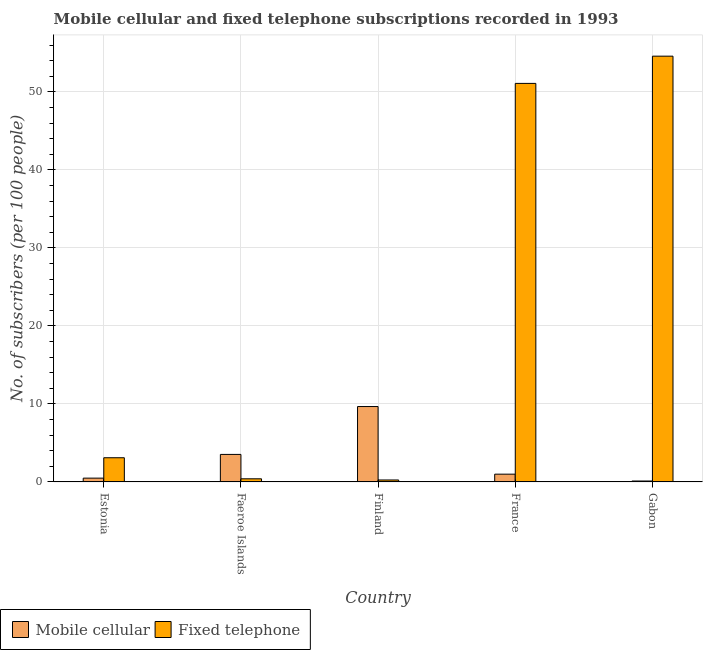How many different coloured bars are there?
Your answer should be compact. 2. How many groups of bars are there?
Make the answer very short. 5. Are the number of bars per tick equal to the number of legend labels?
Offer a terse response. Yes. Are the number of bars on each tick of the X-axis equal?
Your response must be concise. Yes. How many bars are there on the 4th tick from the left?
Provide a short and direct response. 2. What is the number of fixed telephone subscribers in France?
Offer a very short reply. 51.1. Across all countries, what is the maximum number of fixed telephone subscribers?
Ensure brevity in your answer.  54.59. Across all countries, what is the minimum number of fixed telephone subscribers?
Give a very brief answer. 0.25. In which country was the number of mobile cellular subscribers maximum?
Give a very brief answer. Finland. In which country was the number of mobile cellular subscribers minimum?
Give a very brief answer. Gabon. What is the total number of mobile cellular subscribers in the graph?
Give a very brief answer. 14.79. What is the difference between the number of fixed telephone subscribers in Estonia and that in Finland?
Provide a short and direct response. 2.85. What is the difference between the number of mobile cellular subscribers in Estonia and the number of fixed telephone subscribers in France?
Offer a terse response. -50.61. What is the average number of fixed telephone subscribers per country?
Offer a terse response. 21.89. What is the difference between the number of mobile cellular subscribers and number of fixed telephone subscribers in Estonia?
Make the answer very short. -2.62. What is the ratio of the number of mobile cellular subscribers in Estonia to that in Finland?
Keep it short and to the point. 0.05. Is the number of mobile cellular subscribers in Estonia less than that in Finland?
Make the answer very short. Yes. Is the difference between the number of mobile cellular subscribers in France and Gabon greater than the difference between the number of fixed telephone subscribers in France and Gabon?
Give a very brief answer. Yes. What is the difference between the highest and the second highest number of mobile cellular subscribers?
Make the answer very short. 6.14. What is the difference between the highest and the lowest number of fixed telephone subscribers?
Your answer should be compact. 54.34. In how many countries, is the number of mobile cellular subscribers greater than the average number of mobile cellular subscribers taken over all countries?
Ensure brevity in your answer.  2. Is the sum of the number of fixed telephone subscribers in Estonia and Faeroe Islands greater than the maximum number of mobile cellular subscribers across all countries?
Provide a succinct answer. No. What does the 1st bar from the left in Estonia represents?
Keep it short and to the point. Mobile cellular. What does the 1st bar from the right in Finland represents?
Your answer should be compact. Fixed telephone. How many bars are there?
Provide a short and direct response. 10. How many countries are there in the graph?
Offer a very short reply. 5. Are the values on the major ticks of Y-axis written in scientific E-notation?
Ensure brevity in your answer.  No. Does the graph contain any zero values?
Make the answer very short. No. What is the title of the graph?
Offer a very short reply. Mobile cellular and fixed telephone subscriptions recorded in 1993. What is the label or title of the Y-axis?
Your answer should be compact. No. of subscribers (per 100 people). What is the No. of subscribers (per 100 people) in Mobile cellular in Estonia?
Your response must be concise. 0.48. What is the No. of subscribers (per 100 people) of Fixed telephone in Estonia?
Offer a very short reply. 3.1. What is the No. of subscribers (per 100 people) in Mobile cellular in Faeroe Islands?
Provide a succinct answer. 3.53. What is the No. of subscribers (per 100 people) of Fixed telephone in Faeroe Islands?
Keep it short and to the point. 0.4. What is the No. of subscribers (per 100 people) of Mobile cellular in Finland?
Your answer should be compact. 9.66. What is the No. of subscribers (per 100 people) of Fixed telephone in Finland?
Keep it short and to the point. 0.25. What is the No. of subscribers (per 100 people) in Mobile cellular in France?
Your response must be concise. 0.99. What is the No. of subscribers (per 100 people) in Fixed telephone in France?
Your response must be concise. 51.1. What is the No. of subscribers (per 100 people) of Mobile cellular in Gabon?
Make the answer very short. 0.12. What is the No. of subscribers (per 100 people) of Fixed telephone in Gabon?
Offer a very short reply. 54.59. Across all countries, what is the maximum No. of subscribers (per 100 people) of Mobile cellular?
Provide a short and direct response. 9.66. Across all countries, what is the maximum No. of subscribers (per 100 people) of Fixed telephone?
Provide a short and direct response. 54.59. Across all countries, what is the minimum No. of subscribers (per 100 people) of Mobile cellular?
Provide a short and direct response. 0.12. Across all countries, what is the minimum No. of subscribers (per 100 people) in Fixed telephone?
Ensure brevity in your answer.  0.25. What is the total No. of subscribers (per 100 people) of Mobile cellular in the graph?
Offer a very short reply. 14.79. What is the total No. of subscribers (per 100 people) of Fixed telephone in the graph?
Keep it short and to the point. 109.44. What is the difference between the No. of subscribers (per 100 people) of Mobile cellular in Estonia and that in Faeroe Islands?
Offer a terse response. -3.04. What is the difference between the No. of subscribers (per 100 people) in Fixed telephone in Estonia and that in Faeroe Islands?
Provide a succinct answer. 2.7. What is the difference between the No. of subscribers (per 100 people) of Mobile cellular in Estonia and that in Finland?
Ensure brevity in your answer.  -9.18. What is the difference between the No. of subscribers (per 100 people) in Fixed telephone in Estonia and that in Finland?
Provide a short and direct response. 2.85. What is the difference between the No. of subscribers (per 100 people) of Mobile cellular in Estonia and that in France?
Provide a short and direct response. -0.51. What is the difference between the No. of subscribers (per 100 people) of Fixed telephone in Estonia and that in France?
Ensure brevity in your answer.  -48. What is the difference between the No. of subscribers (per 100 people) of Mobile cellular in Estonia and that in Gabon?
Your answer should be compact. 0.37. What is the difference between the No. of subscribers (per 100 people) of Fixed telephone in Estonia and that in Gabon?
Ensure brevity in your answer.  -51.49. What is the difference between the No. of subscribers (per 100 people) of Mobile cellular in Faeroe Islands and that in Finland?
Make the answer very short. -6.14. What is the difference between the No. of subscribers (per 100 people) of Fixed telephone in Faeroe Islands and that in Finland?
Keep it short and to the point. 0.15. What is the difference between the No. of subscribers (per 100 people) in Mobile cellular in Faeroe Islands and that in France?
Offer a very short reply. 2.53. What is the difference between the No. of subscribers (per 100 people) of Fixed telephone in Faeroe Islands and that in France?
Your response must be concise. -50.7. What is the difference between the No. of subscribers (per 100 people) in Mobile cellular in Faeroe Islands and that in Gabon?
Give a very brief answer. 3.41. What is the difference between the No. of subscribers (per 100 people) in Fixed telephone in Faeroe Islands and that in Gabon?
Ensure brevity in your answer.  -54.19. What is the difference between the No. of subscribers (per 100 people) of Mobile cellular in Finland and that in France?
Provide a short and direct response. 8.67. What is the difference between the No. of subscribers (per 100 people) of Fixed telephone in Finland and that in France?
Offer a very short reply. -50.85. What is the difference between the No. of subscribers (per 100 people) in Mobile cellular in Finland and that in Gabon?
Your answer should be compact. 9.55. What is the difference between the No. of subscribers (per 100 people) in Fixed telephone in Finland and that in Gabon?
Offer a terse response. -54.34. What is the difference between the No. of subscribers (per 100 people) in Mobile cellular in France and that in Gabon?
Give a very brief answer. 0.88. What is the difference between the No. of subscribers (per 100 people) of Fixed telephone in France and that in Gabon?
Make the answer very short. -3.49. What is the difference between the No. of subscribers (per 100 people) of Mobile cellular in Estonia and the No. of subscribers (per 100 people) of Fixed telephone in Faeroe Islands?
Your answer should be very brief. 0.09. What is the difference between the No. of subscribers (per 100 people) in Mobile cellular in Estonia and the No. of subscribers (per 100 people) in Fixed telephone in Finland?
Your response must be concise. 0.24. What is the difference between the No. of subscribers (per 100 people) of Mobile cellular in Estonia and the No. of subscribers (per 100 people) of Fixed telephone in France?
Ensure brevity in your answer.  -50.61. What is the difference between the No. of subscribers (per 100 people) of Mobile cellular in Estonia and the No. of subscribers (per 100 people) of Fixed telephone in Gabon?
Give a very brief answer. -54.11. What is the difference between the No. of subscribers (per 100 people) of Mobile cellular in Faeroe Islands and the No. of subscribers (per 100 people) of Fixed telephone in Finland?
Your answer should be compact. 3.28. What is the difference between the No. of subscribers (per 100 people) in Mobile cellular in Faeroe Islands and the No. of subscribers (per 100 people) in Fixed telephone in France?
Your answer should be compact. -47.57. What is the difference between the No. of subscribers (per 100 people) of Mobile cellular in Faeroe Islands and the No. of subscribers (per 100 people) of Fixed telephone in Gabon?
Your response must be concise. -51.06. What is the difference between the No. of subscribers (per 100 people) of Mobile cellular in Finland and the No. of subscribers (per 100 people) of Fixed telephone in France?
Provide a short and direct response. -41.43. What is the difference between the No. of subscribers (per 100 people) of Mobile cellular in Finland and the No. of subscribers (per 100 people) of Fixed telephone in Gabon?
Ensure brevity in your answer.  -44.93. What is the difference between the No. of subscribers (per 100 people) of Mobile cellular in France and the No. of subscribers (per 100 people) of Fixed telephone in Gabon?
Keep it short and to the point. -53.6. What is the average No. of subscribers (per 100 people) of Mobile cellular per country?
Offer a very short reply. 2.96. What is the average No. of subscribers (per 100 people) in Fixed telephone per country?
Your answer should be very brief. 21.89. What is the difference between the No. of subscribers (per 100 people) in Mobile cellular and No. of subscribers (per 100 people) in Fixed telephone in Estonia?
Keep it short and to the point. -2.62. What is the difference between the No. of subscribers (per 100 people) in Mobile cellular and No. of subscribers (per 100 people) in Fixed telephone in Faeroe Islands?
Offer a terse response. 3.13. What is the difference between the No. of subscribers (per 100 people) in Mobile cellular and No. of subscribers (per 100 people) in Fixed telephone in Finland?
Ensure brevity in your answer.  9.42. What is the difference between the No. of subscribers (per 100 people) in Mobile cellular and No. of subscribers (per 100 people) in Fixed telephone in France?
Your response must be concise. -50.1. What is the difference between the No. of subscribers (per 100 people) in Mobile cellular and No. of subscribers (per 100 people) in Fixed telephone in Gabon?
Make the answer very short. -54.47. What is the ratio of the No. of subscribers (per 100 people) in Mobile cellular in Estonia to that in Faeroe Islands?
Your answer should be compact. 0.14. What is the ratio of the No. of subscribers (per 100 people) in Fixed telephone in Estonia to that in Faeroe Islands?
Provide a succinct answer. 7.77. What is the ratio of the No. of subscribers (per 100 people) in Mobile cellular in Estonia to that in Finland?
Your answer should be compact. 0.05. What is the ratio of the No. of subscribers (per 100 people) of Fixed telephone in Estonia to that in Finland?
Your answer should be very brief. 12.48. What is the ratio of the No. of subscribers (per 100 people) of Mobile cellular in Estonia to that in France?
Ensure brevity in your answer.  0.49. What is the ratio of the No. of subscribers (per 100 people) of Fixed telephone in Estonia to that in France?
Provide a short and direct response. 0.06. What is the ratio of the No. of subscribers (per 100 people) of Mobile cellular in Estonia to that in Gabon?
Your response must be concise. 4.14. What is the ratio of the No. of subscribers (per 100 people) in Fixed telephone in Estonia to that in Gabon?
Your answer should be compact. 0.06. What is the ratio of the No. of subscribers (per 100 people) in Mobile cellular in Faeroe Islands to that in Finland?
Provide a short and direct response. 0.36. What is the ratio of the No. of subscribers (per 100 people) of Fixed telephone in Faeroe Islands to that in Finland?
Provide a succinct answer. 1.61. What is the ratio of the No. of subscribers (per 100 people) of Mobile cellular in Faeroe Islands to that in France?
Offer a very short reply. 3.55. What is the ratio of the No. of subscribers (per 100 people) of Fixed telephone in Faeroe Islands to that in France?
Your answer should be compact. 0.01. What is the ratio of the No. of subscribers (per 100 people) in Mobile cellular in Faeroe Islands to that in Gabon?
Provide a succinct answer. 30.14. What is the ratio of the No. of subscribers (per 100 people) in Fixed telephone in Faeroe Islands to that in Gabon?
Give a very brief answer. 0.01. What is the ratio of the No. of subscribers (per 100 people) in Mobile cellular in Finland to that in France?
Provide a short and direct response. 9.73. What is the ratio of the No. of subscribers (per 100 people) in Fixed telephone in Finland to that in France?
Ensure brevity in your answer.  0. What is the ratio of the No. of subscribers (per 100 people) of Mobile cellular in Finland to that in Gabon?
Keep it short and to the point. 82.6. What is the ratio of the No. of subscribers (per 100 people) in Fixed telephone in Finland to that in Gabon?
Provide a short and direct response. 0. What is the ratio of the No. of subscribers (per 100 people) of Mobile cellular in France to that in Gabon?
Keep it short and to the point. 8.49. What is the ratio of the No. of subscribers (per 100 people) of Fixed telephone in France to that in Gabon?
Your response must be concise. 0.94. What is the difference between the highest and the second highest No. of subscribers (per 100 people) of Mobile cellular?
Keep it short and to the point. 6.14. What is the difference between the highest and the second highest No. of subscribers (per 100 people) of Fixed telephone?
Offer a very short reply. 3.49. What is the difference between the highest and the lowest No. of subscribers (per 100 people) of Mobile cellular?
Provide a short and direct response. 9.55. What is the difference between the highest and the lowest No. of subscribers (per 100 people) in Fixed telephone?
Keep it short and to the point. 54.34. 